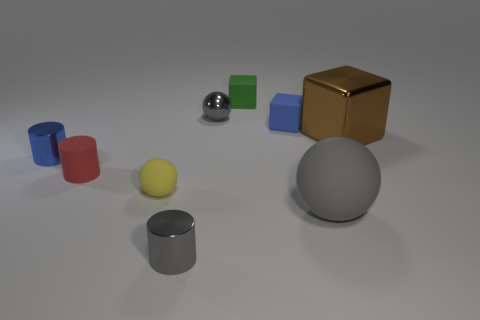Subtract all balls. How many objects are left? 6 Subtract 0 blue balls. How many objects are left? 9 Subtract all tiny yellow rubber balls. Subtract all tiny yellow matte things. How many objects are left? 7 Add 8 red things. How many red things are left? 9 Add 9 yellow spheres. How many yellow spheres exist? 10 